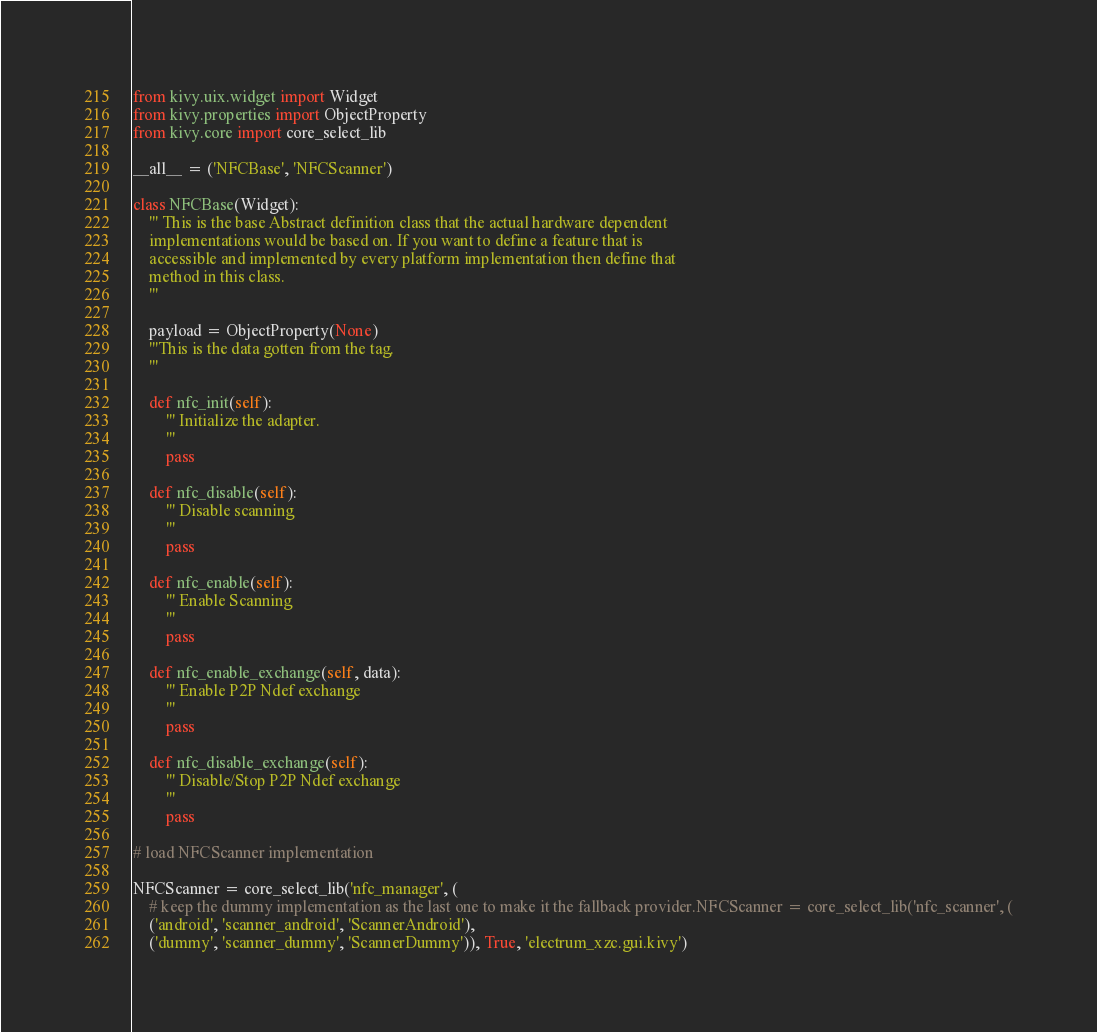Convert code to text. <code><loc_0><loc_0><loc_500><loc_500><_Python_>from kivy.uix.widget import Widget
from kivy.properties import ObjectProperty
from kivy.core import core_select_lib

__all__ = ('NFCBase', 'NFCScanner')

class NFCBase(Widget):
    ''' This is the base Abstract definition class that the actual hardware dependent
    implementations would be based on. If you want to define a feature that is
    accessible and implemented by every platform implementation then define that
    method in this class.
    '''

    payload = ObjectProperty(None)
    '''This is the data gotten from the tag. 
    '''

    def nfc_init(self):
        ''' Initialize the adapter.
        '''
        pass

    def nfc_disable(self):
        ''' Disable scanning
        '''
        pass

    def nfc_enable(self):
        ''' Enable Scanning
        '''
        pass

    def nfc_enable_exchange(self, data):
        ''' Enable P2P Ndef exchange
        '''
        pass

    def nfc_disable_exchange(self):
        ''' Disable/Stop P2P Ndef exchange
        '''
        pass

# load NFCScanner implementation

NFCScanner = core_select_lib('nfc_manager', (
    # keep the dummy implementation as the last one to make it the fallback provider.NFCScanner = core_select_lib('nfc_scanner', (
    ('android', 'scanner_android', 'ScannerAndroid'),
    ('dummy', 'scanner_dummy', 'ScannerDummy')), True, 'electrum_xzc.gui.kivy')
</code> 